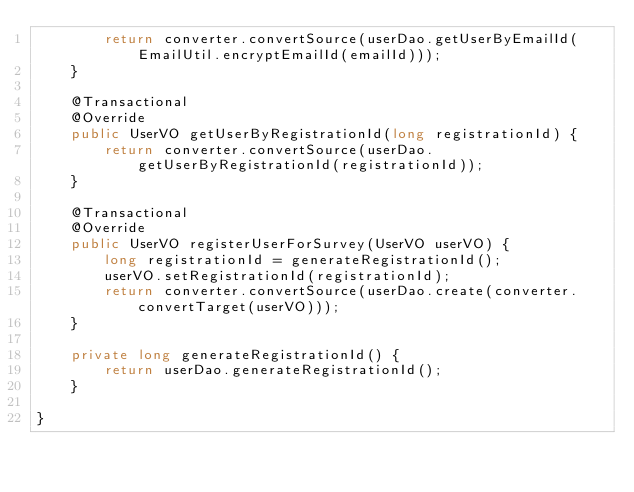<code> <loc_0><loc_0><loc_500><loc_500><_Java_>        return converter.convertSource(userDao.getUserByEmailId(EmailUtil.encryptEmailId(emailId)));
    }
    
    @Transactional
    @Override
    public UserVO getUserByRegistrationId(long registrationId) {
        return converter.convertSource(userDao.getUserByRegistrationId(registrationId));
    }
    
    @Transactional
    @Override
    public UserVO registerUserForSurvey(UserVO userVO) {
        long registrationId = generateRegistrationId();
        userVO.setRegistrationId(registrationId);
        return converter.convertSource(userDao.create(converter.convertTarget(userVO)));
    }
    
    private long generateRegistrationId() {
        return userDao.generateRegistrationId();
    }
    
}
</code> 